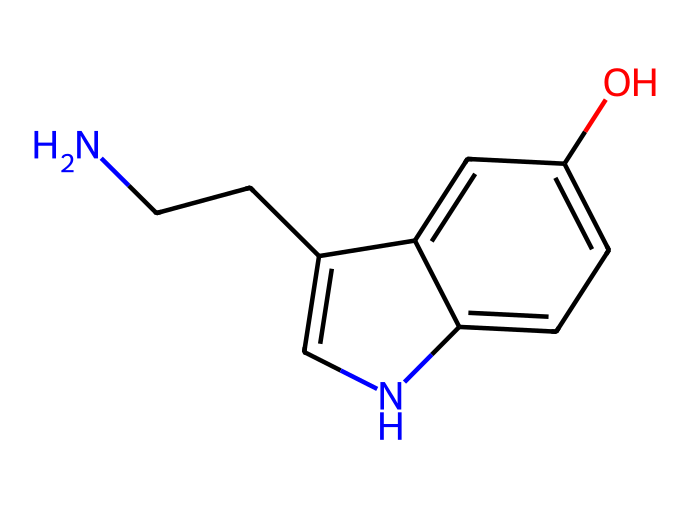What is the molecular formula of this neurotransmitter? By analyzing the SMILES representation, we can identify each atom present. The structure contains two nitrogen (N) atoms, nine carbon (C) atoms, and eleven hydrogen (H) atoms, along with one oxygen (O) atom. Combining these gives the molecular formula C10H12N2O.
Answer: C10H12N2O How many rings are present in this molecular structure? The SMILES indicates the presence of a cyclic structure denoted by pairs of numbers, which refer to the atoms forming the rings. Based on the structure, there are two cyclic components, so there are two rings.
Answer: 2 What functional group is represented in this chemical? A hydroxyl (-OH) group can be identified in the structure (as part of the benzene ring). This functional group is characteristic of alcohols and is responsible for some of its chemical properties.
Answer: hydroxyl group Which atom serves as a primary amine in this structure? The molecular structure shows an amine group (-NH2) attached to a carbon (C) atom. The nitrogen atom that is directly bonded to one carbon and two hydrogens is the primary amine.
Answer: nitrogen atom What type of bond connects the atoms in the aromatic ring? The aromatic ring consists of alternating single and double bonds, which are characteristic of aromatic compounds. These bonds result in resonance among the carbons, which stabilizes the structure.
Answer: alternating single and double bonds What is the role of serotonin in the human body? Serotonin plays a critical role as a neurotransmitter, particularly linked to regulating mood, sleep, and writing productivity. It affects mood balance and emotional well-being.
Answer: neurotransmitter 